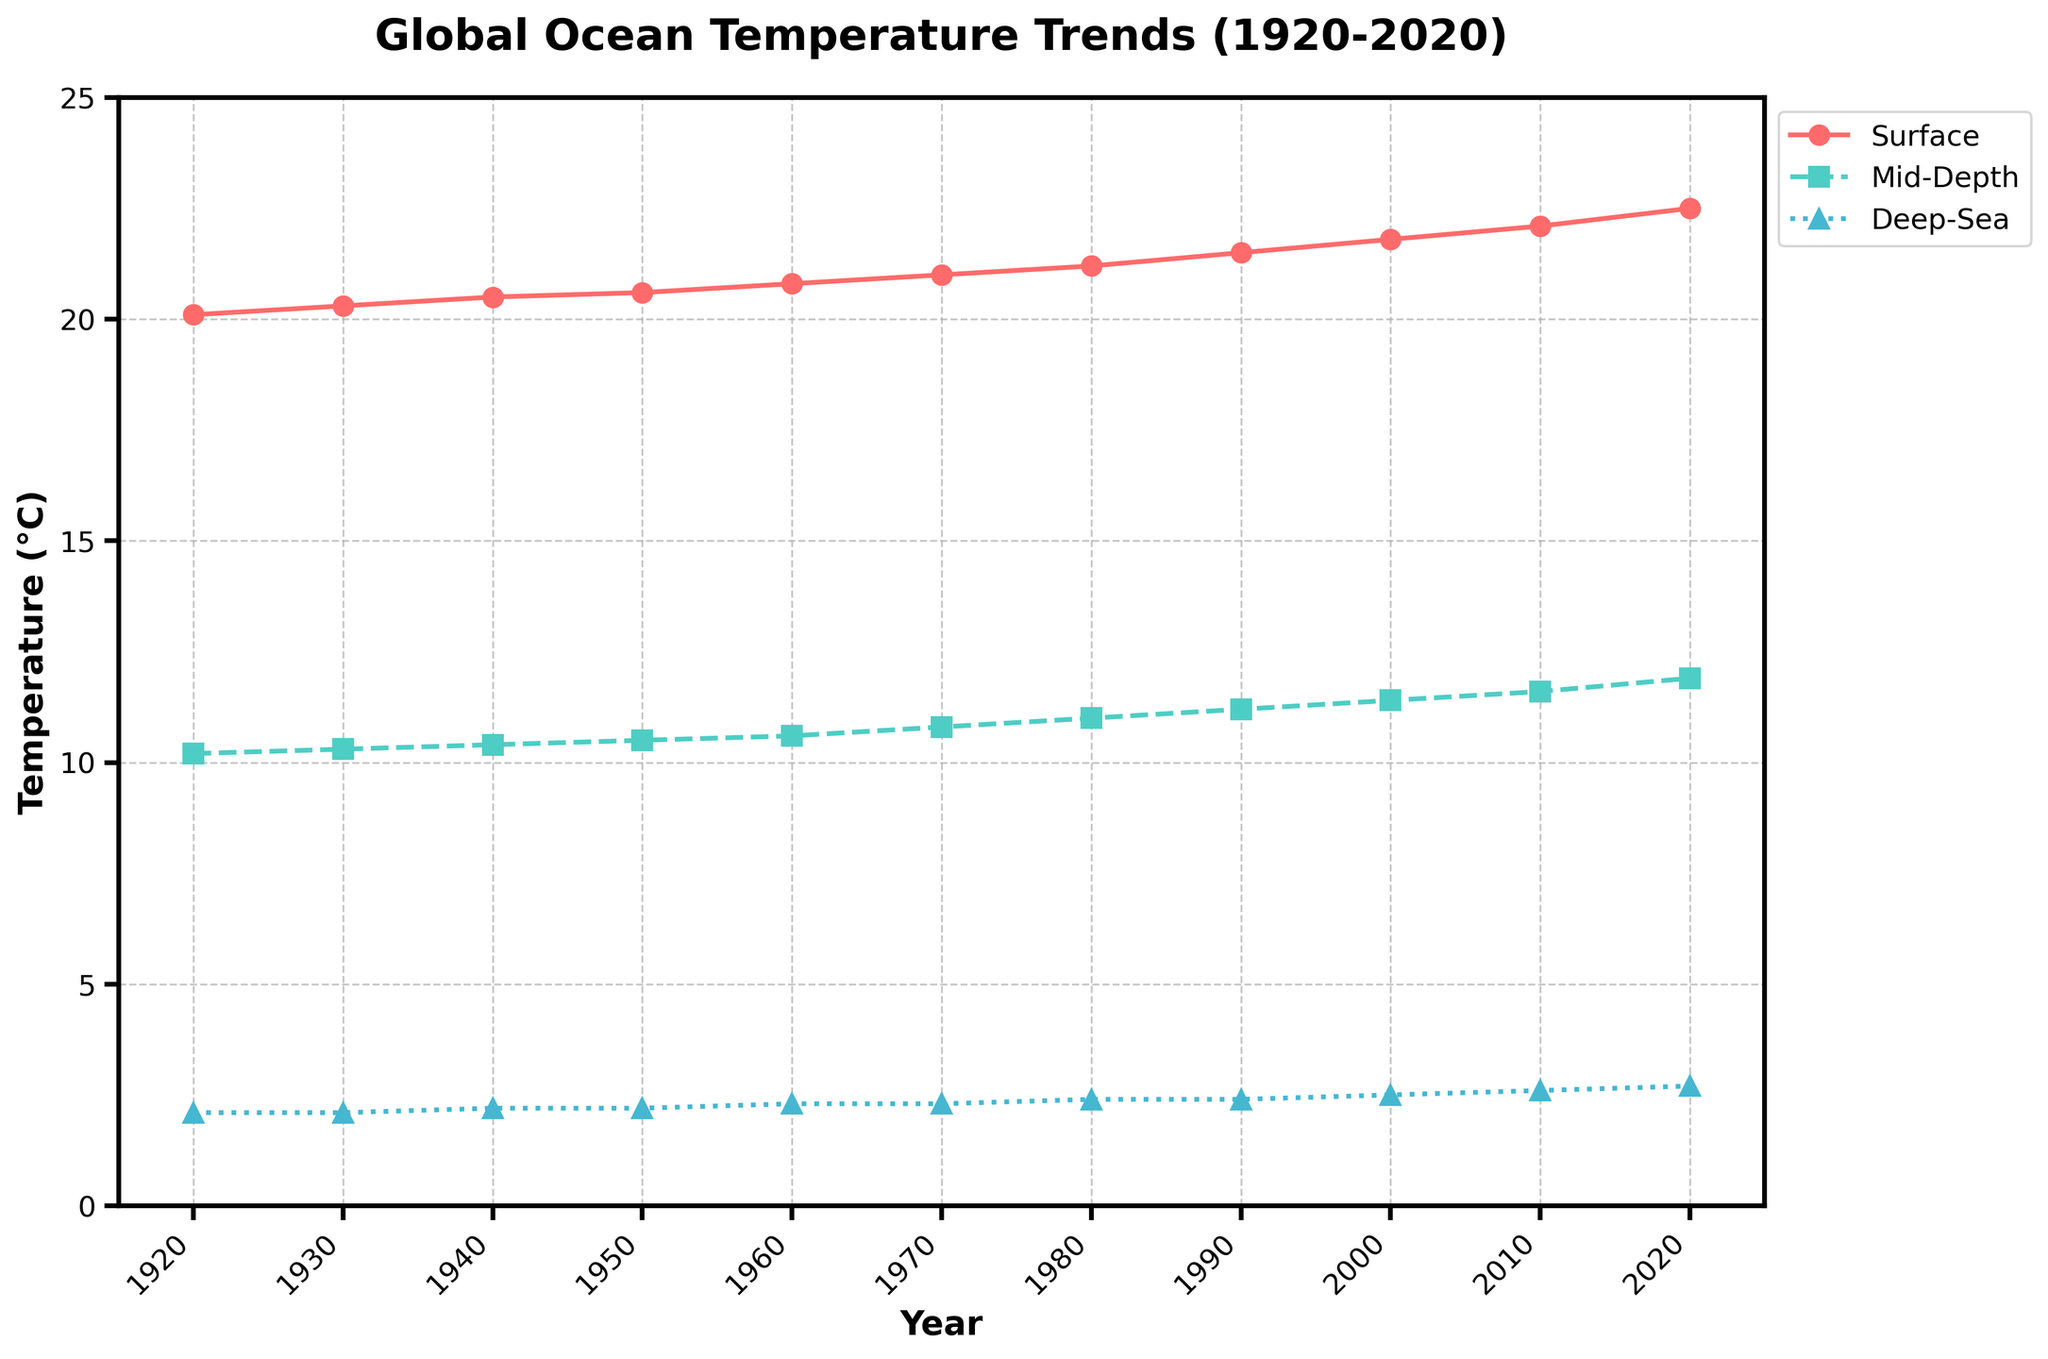What is the highest surface temperature recorded during the given period? The line representing the surface temperature reaches its highest point in 2020. According to the y-axis on the graph, this value is 22.5 °C.
Answer: 22.5 °C How does the surface temperature in 1920 compare to 2020's surface temperature? In 1920, the surface temperature is 20.1 °C. In 2020, it is 22.5 °C. The difference is calculated as 22.5 - 20.1 = 2.4 °C, indicating an increase.
Answer: 2.4 °C increase Which layer shows the smallest temperature change between 1920 and 2020? Calculate the difference for each layer: Surface (22.5 - 20.1 = 2.4 °C), Mid-Depth (11.9 - 10.2 = 1.7 °C), Deep-Sea (2.7 - 2.1 = 0.6 °C). The smallest change is in the Deep-Sea layer.
Answer: Deep-Sea Approximately in what decade do all temperature layers show a noticeable increase? By observing the lines and markers, all layers (surface, mid-depth, deep-sea) begin showing a noticeable rise around the 1970s-1980s.
Answer: 1970s-1980s What is the difference between mid-depth and deep-sea temperatures in 2010? Look at 2010 data points on the y-axis: Mid-Depth temperature is 11.6 °C and Deep-Sea temperature is 2.6 °C. Subtract the two: 11.6 - 2.6 = 9 °C.
Answer: 9 °C What are the temperature values for each layer in the year 1960? Check 1960 values from y-axis: Surface: 20.8 °C, Mid-Depth: 10.6 °C, Deep-Sea: 2.3 °C.
Answer: Surface: 20.8 °C, Mid-Depth: 10.6 °C, Deep-Sea: 2.3 °C How many years after 1920 does the surface temperature reach 21 °C? Surface temperature hits 21 °C around 1970. Thus, 1970 - 1920 = 50 years later.
Answer: 50 years In which decade did the deep-sea temperature first rise above 2.2 °C? The deep-sea temperature surpasses 2.2 °C in the 1960s. According to the chart, it reaches 2.3 °C in 1960.
Answer: 1960s 